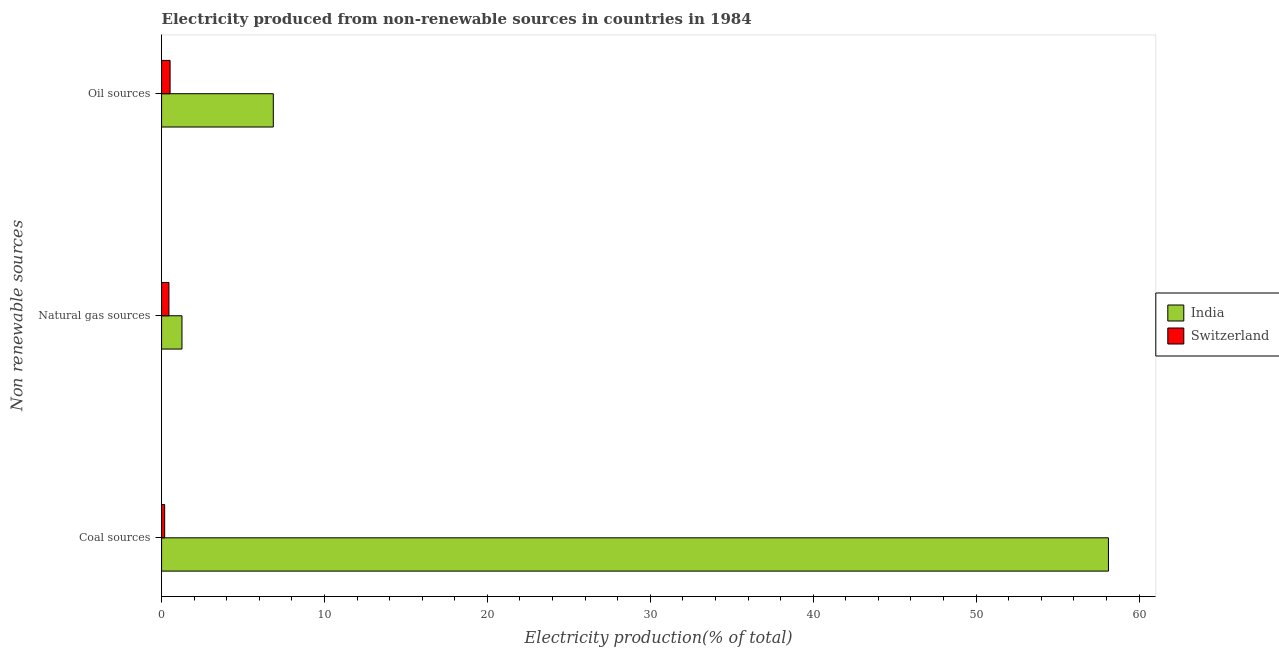How many different coloured bars are there?
Make the answer very short. 2. How many groups of bars are there?
Give a very brief answer. 3. Are the number of bars per tick equal to the number of legend labels?
Keep it short and to the point. Yes. Are the number of bars on each tick of the Y-axis equal?
Provide a short and direct response. Yes. How many bars are there on the 3rd tick from the top?
Give a very brief answer. 2. How many bars are there on the 2nd tick from the bottom?
Offer a terse response. 2. What is the label of the 1st group of bars from the top?
Offer a very short reply. Oil sources. What is the percentage of electricity produced by coal in Switzerland?
Offer a very short reply. 0.19. Across all countries, what is the maximum percentage of electricity produced by coal?
Provide a succinct answer. 58.12. Across all countries, what is the minimum percentage of electricity produced by oil sources?
Your answer should be very brief. 0.52. In which country was the percentage of electricity produced by coal maximum?
Offer a very short reply. India. In which country was the percentage of electricity produced by coal minimum?
Offer a very short reply. Switzerland. What is the total percentage of electricity produced by coal in the graph?
Offer a very short reply. 58.31. What is the difference between the percentage of electricity produced by natural gas in India and that in Switzerland?
Ensure brevity in your answer.  0.8. What is the difference between the percentage of electricity produced by natural gas in India and the percentage of electricity produced by coal in Switzerland?
Your answer should be very brief. 1.06. What is the average percentage of electricity produced by oil sources per country?
Your answer should be compact. 3.69. What is the difference between the percentage of electricity produced by oil sources and percentage of electricity produced by coal in India?
Offer a terse response. -51.26. In how many countries, is the percentage of electricity produced by natural gas greater than 54 %?
Provide a succinct answer. 0. What is the ratio of the percentage of electricity produced by natural gas in Switzerland to that in India?
Offer a terse response. 0.36. Is the percentage of electricity produced by coal in Switzerland less than that in India?
Provide a short and direct response. Yes. What is the difference between the highest and the second highest percentage of electricity produced by natural gas?
Offer a very short reply. 0.8. What is the difference between the highest and the lowest percentage of electricity produced by oil sources?
Provide a succinct answer. 6.34. Is the sum of the percentage of electricity produced by oil sources in India and Switzerland greater than the maximum percentage of electricity produced by coal across all countries?
Offer a very short reply. No. What does the 2nd bar from the top in Coal sources represents?
Make the answer very short. India. What does the 2nd bar from the bottom in Coal sources represents?
Provide a succinct answer. Switzerland. Is it the case that in every country, the sum of the percentage of electricity produced by coal and percentage of electricity produced by natural gas is greater than the percentage of electricity produced by oil sources?
Your response must be concise. Yes. How many countries are there in the graph?
Ensure brevity in your answer.  2. What is the difference between two consecutive major ticks on the X-axis?
Your answer should be compact. 10. Does the graph contain any zero values?
Offer a terse response. No. Does the graph contain grids?
Your answer should be very brief. No. What is the title of the graph?
Keep it short and to the point. Electricity produced from non-renewable sources in countries in 1984. Does "Caribbean small states" appear as one of the legend labels in the graph?
Make the answer very short. No. What is the label or title of the Y-axis?
Ensure brevity in your answer.  Non renewable sources. What is the Electricity production(% of total) in India in Coal sources?
Keep it short and to the point. 58.12. What is the Electricity production(% of total) of Switzerland in Coal sources?
Your response must be concise. 0.19. What is the Electricity production(% of total) in India in Natural gas sources?
Your answer should be very brief. 1.25. What is the Electricity production(% of total) of Switzerland in Natural gas sources?
Your answer should be compact. 0.45. What is the Electricity production(% of total) of India in Oil sources?
Offer a terse response. 6.86. What is the Electricity production(% of total) of Switzerland in Oil sources?
Make the answer very short. 0.52. Across all Non renewable sources, what is the maximum Electricity production(% of total) in India?
Your answer should be compact. 58.12. Across all Non renewable sources, what is the maximum Electricity production(% of total) of Switzerland?
Your answer should be very brief. 0.52. Across all Non renewable sources, what is the minimum Electricity production(% of total) in India?
Ensure brevity in your answer.  1.25. Across all Non renewable sources, what is the minimum Electricity production(% of total) in Switzerland?
Make the answer very short. 0.19. What is the total Electricity production(% of total) in India in the graph?
Offer a terse response. 66.23. What is the total Electricity production(% of total) of Switzerland in the graph?
Provide a short and direct response. 1.16. What is the difference between the Electricity production(% of total) of India in Coal sources and that in Natural gas sources?
Ensure brevity in your answer.  56.87. What is the difference between the Electricity production(% of total) in Switzerland in Coal sources and that in Natural gas sources?
Ensure brevity in your answer.  -0.26. What is the difference between the Electricity production(% of total) of India in Coal sources and that in Oil sources?
Keep it short and to the point. 51.26. What is the difference between the Electricity production(% of total) of Switzerland in Coal sources and that in Oil sources?
Provide a succinct answer. -0.33. What is the difference between the Electricity production(% of total) of India in Natural gas sources and that in Oil sources?
Give a very brief answer. -5.61. What is the difference between the Electricity production(% of total) of Switzerland in Natural gas sources and that in Oil sources?
Your answer should be compact. -0.07. What is the difference between the Electricity production(% of total) in India in Coal sources and the Electricity production(% of total) in Switzerland in Natural gas sources?
Your answer should be compact. 57.67. What is the difference between the Electricity production(% of total) of India in Coal sources and the Electricity production(% of total) of Switzerland in Oil sources?
Your response must be concise. 57.6. What is the difference between the Electricity production(% of total) in India in Natural gas sources and the Electricity production(% of total) in Switzerland in Oil sources?
Provide a succinct answer. 0.73. What is the average Electricity production(% of total) of India per Non renewable sources?
Make the answer very short. 22.08. What is the average Electricity production(% of total) of Switzerland per Non renewable sources?
Your answer should be very brief. 0.39. What is the difference between the Electricity production(% of total) of India and Electricity production(% of total) of Switzerland in Coal sources?
Offer a very short reply. 57.93. What is the difference between the Electricity production(% of total) of India and Electricity production(% of total) of Switzerland in Natural gas sources?
Provide a short and direct response. 0.8. What is the difference between the Electricity production(% of total) of India and Electricity production(% of total) of Switzerland in Oil sources?
Your response must be concise. 6.34. What is the ratio of the Electricity production(% of total) of India in Coal sources to that in Natural gas sources?
Make the answer very short. 46.44. What is the ratio of the Electricity production(% of total) in Switzerland in Coal sources to that in Natural gas sources?
Offer a terse response. 0.42. What is the ratio of the Electricity production(% of total) in India in Coal sources to that in Oil sources?
Ensure brevity in your answer.  8.47. What is the ratio of the Electricity production(% of total) in Switzerland in Coal sources to that in Oil sources?
Your answer should be compact. 0.36. What is the ratio of the Electricity production(% of total) of India in Natural gas sources to that in Oil sources?
Offer a very short reply. 0.18. What is the ratio of the Electricity production(% of total) of Switzerland in Natural gas sources to that in Oil sources?
Offer a terse response. 0.86. What is the difference between the highest and the second highest Electricity production(% of total) in India?
Keep it short and to the point. 51.26. What is the difference between the highest and the second highest Electricity production(% of total) of Switzerland?
Ensure brevity in your answer.  0.07. What is the difference between the highest and the lowest Electricity production(% of total) of India?
Your answer should be compact. 56.87. What is the difference between the highest and the lowest Electricity production(% of total) in Switzerland?
Offer a very short reply. 0.33. 